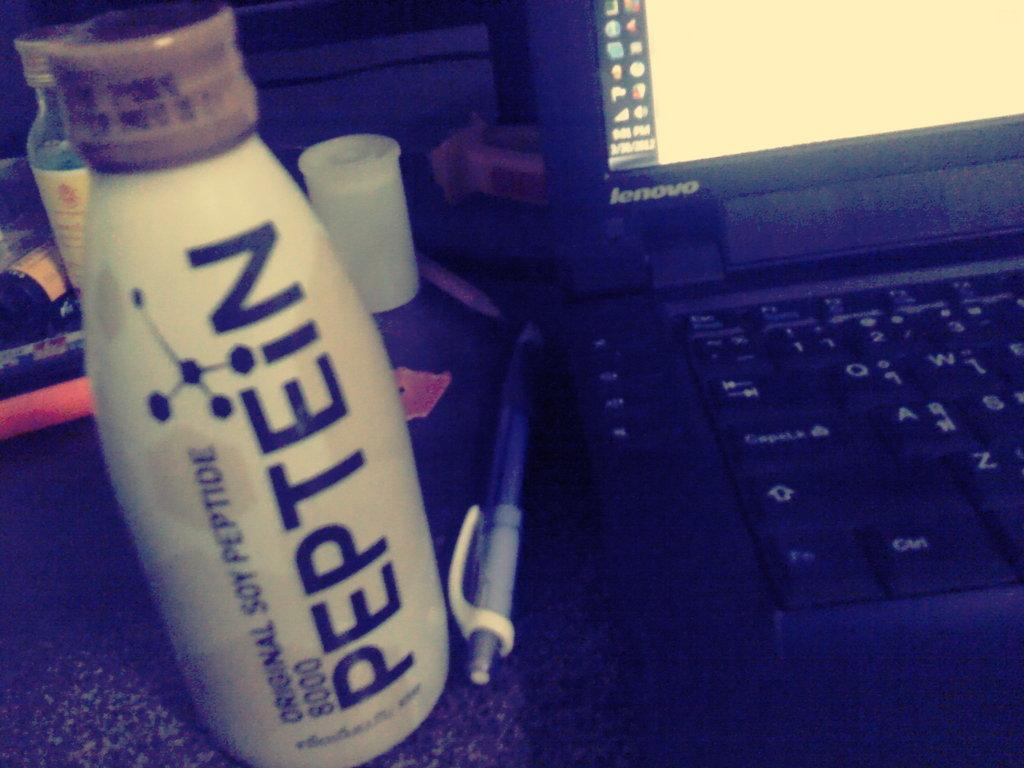<image>
Render a clear and concise summary of the photo. a bottle of Peptein next to an opened laptop 